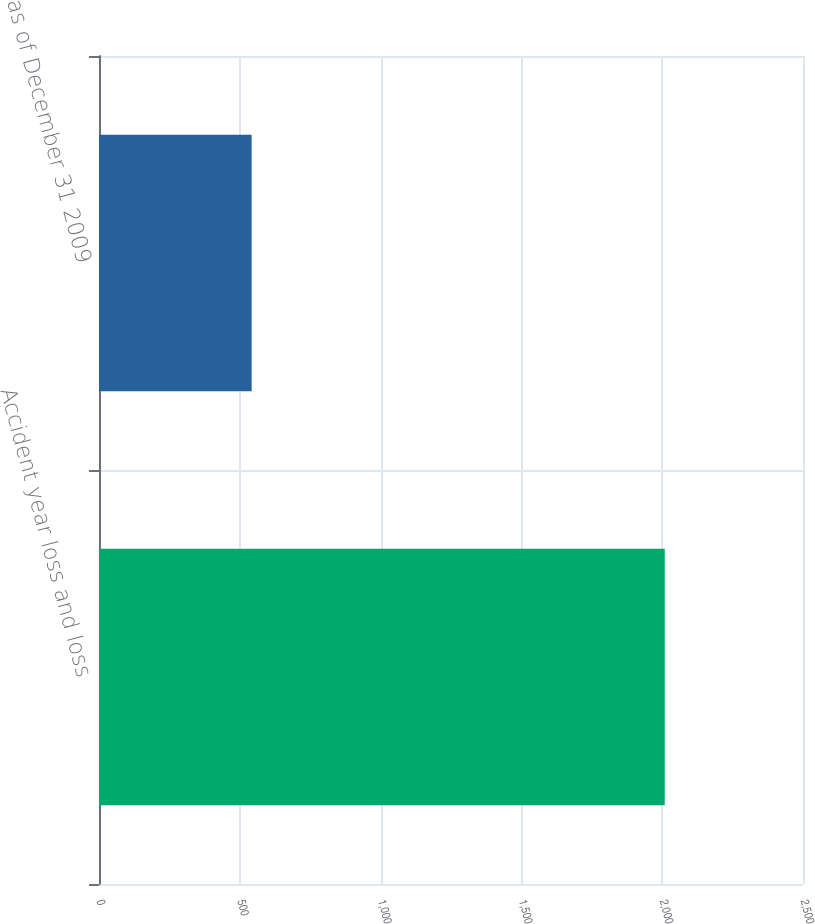<chart> <loc_0><loc_0><loc_500><loc_500><bar_chart><fcel>Accident year loss and loss<fcel>as of December 31 2009<nl><fcel>2009<fcel>542<nl></chart> 